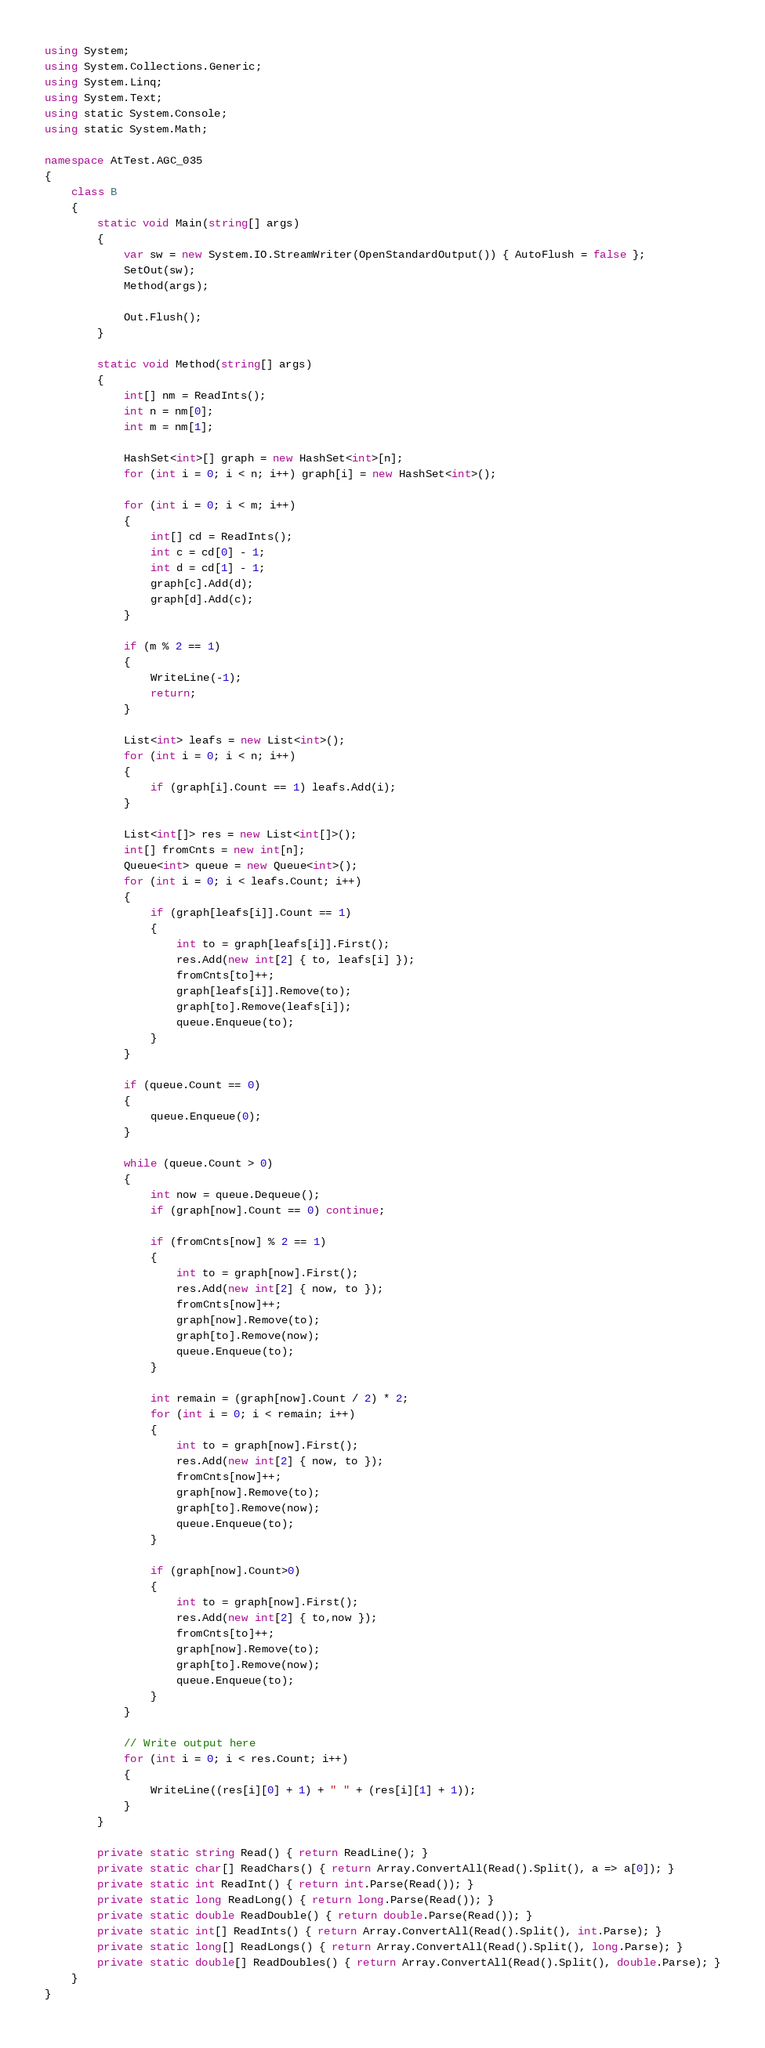<code> <loc_0><loc_0><loc_500><loc_500><_C#_>using System;
using System.Collections.Generic;
using System.Linq;
using System.Text;
using static System.Console;
using static System.Math;

namespace AtTest.AGC_035
{
    class B
    {
        static void Main(string[] args)
        {
            var sw = new System.IO.StreamWriter(OpenStandardOutput()) { AutoFlush = false };
            SetOut(sw);
            Method(args);

            Out.Flush();
        }

        static void Method(string[] args)
        {
            int[] nm = ReadInts();
            int n = nm[0];
            int m = nm[1];

            HashSet<int>[] graph = new HashSet<int>[n];
            for (int i = 0; i < n; i++) graph[i] = new HashSet<int>();

            for (int i = 0; i < m; i++)
            {
                int[] cd = ReadInts();
                int c = cd[0] - 1;
                int d = cd[1] - 1;
                graph[c].Add(d);
                graph[d].Add(c);
            }

            if (m % 2 == 1)
            {
                WriteLine(-1);
                return;
            }

            List<int> leafs = new List<int>();
            for (int i = 0; i < n; i++)
            {
                if (graph[i].Count == 1) leafs.Add(i);
            }

            List<int[]> res = new List<int[]>();
            int[] fromCnts = new int[n];
            Queue<int> queue = new Queue<int>();
            for (int i = 0; i < leafs.Count; i++)
            {
                if (graph[leafs[i]].Count == 1)
                {
                    int to = graph[leafs[i]].First();
                    res.Add(new int[2] { to, leafs[i] });
                    fromCnts[to]++;
                    graph[leafs[i]].Remove(to);
                    graph[to].Remove(leafs[i]);
                    queue.Enqueue(to);
                }
            }

            if (queue.Count == 0)
            {
                queue.Enqueue(0);
            }

            while (queue.Count > 0)
            {
                int now = queue.Dequeue();
                if (graph[now].Count == 0) continue;

                if (fromCnts[now] % 2 == 1)
                {
                    int to = graph[now].First();
                    res.Add(new int[2] { now, to });
                    fromCnts[now]++;
                    graph[now].Remove(to);
                    graph[to].Remove(now);
                    queue.Enqueue(to);
                }

                int remain = (graph[now].Count / 2) * 2;
                for (int i = 0; i < remain; i++)
                {
                    int to = graph[now].First();
                    res.Add(new int[2] { now, to });
                    fromCnts[now]++;
                    graph[now].Remove(to);
                    graph[to].Remove(now);
                    queue.Enqueue(to);
                }

                if (graph[now].Count>0)
                {
                    int to = graph[now].First();
                    res.Add(new int[2] { to,now });
                    fromCnts[to]++;
                    graph[now].Remove(to);
                    graph[to].Remove(now);
                    queue.Enqueue(to);
                }
            }

            // Write output here
            for (int i = 0; i < res.Count; i++)
            {
                WriteLine((res[i][0] + 1) + " " + (res[i][1] + 1));
            }
        }

        private static string Read() { return ReadLine(); }
        private static char[] ReadChars() { return Array.ConvertAll(Read().Split(), a => a[0]); }
        private static int ReadInt() { return int.Parse(Read()); }
        private static long ReadLong() { return long.Parse(Read()); }
        private static double ReadDouble() { return double.Parse(Read()); }
        private static int[] ReadInts() { return Array.ConvertAll(Read().Split(), int.Parse); }
        private static long[] ReadLongs() { return Array.ConvertAll(Read().Split(), long.Parse); }
        private static double[] ReadDoubles() { return Array.ConvertAll(Read().Split(), double.Parse); }
    }
}
</code> 